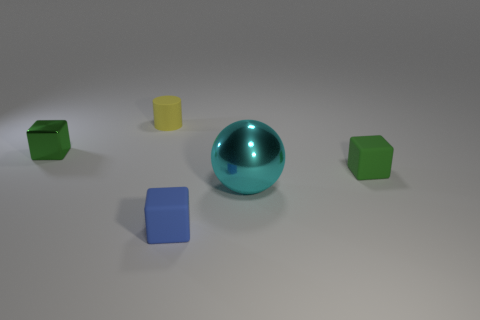Add 1 small rubber objects. How many objects exist? 6 Subtract all cylinders. How many objects are left? 4 Add 3 small blue matte things. How many small blue matte things exist? 4 Subtract 0 blue spheres. How many objects are left? 5 Subtract all tiny yellow matte cylinders. Subtract all purple metallic things. How many objects are left? 4 Add 5 rubber cubes. How many rubber cubes are left? 7 